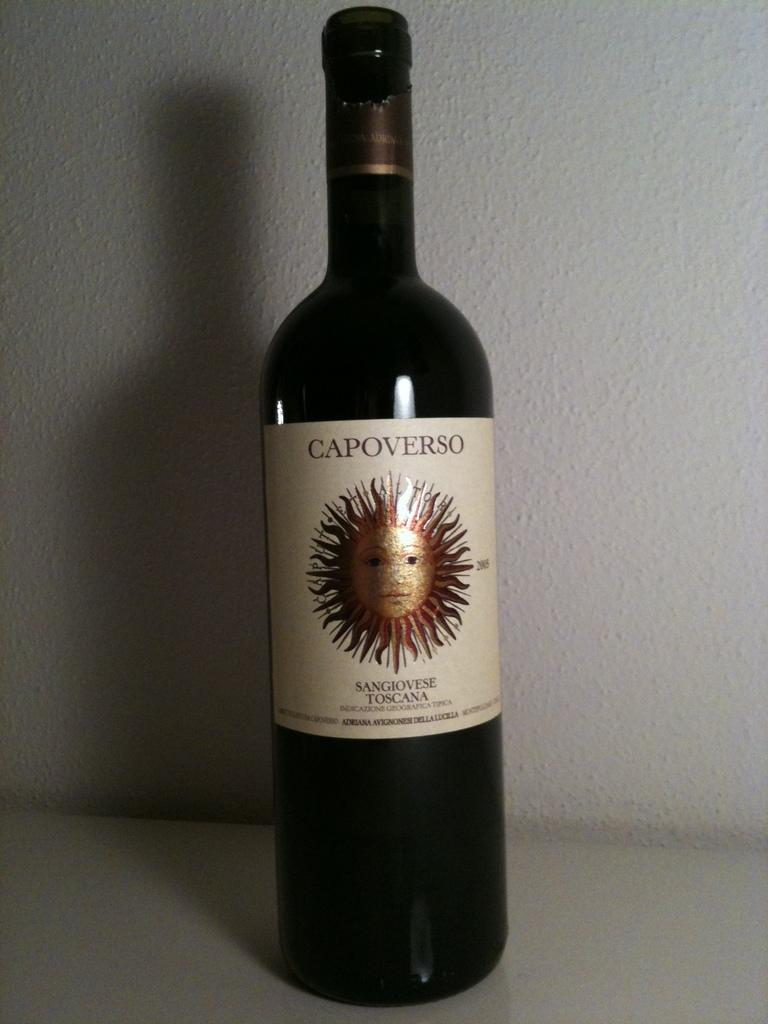<image>
Render a clear and concise summary of the photo. A bottle of Capoverso Sangiovese Toscana wine against a white wall. 